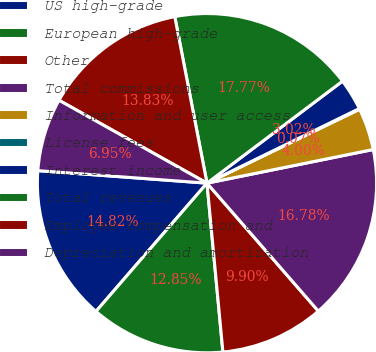Convert chart. <chart><loc_0><loc_0><loc_500><loc_500><pie_chart><fcel>US high-grade<fcel>European high-grade<fcel>Other<fcel>Total commissions<fcel>Information and user access<fcel>License fees<fcel>Interest income<fcel>Total revenues<fcel>Employee compensation and<fcel>Depreciation and amortization<nl><fcel>14.82%<fcel>12.85%<fcel>9.9%<fcel>16.78%<fcel>4.0%<fcel>0.07%<fcel>3.02%<fcel>17.77%<fcel>13.83%<fcel>6.95%<nl></chart> 